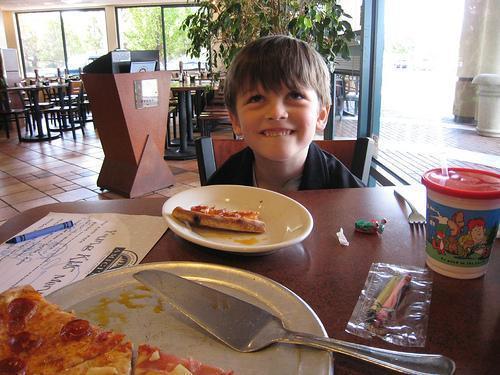How many pieces has he already had?
Give a very brief answer. 1. 